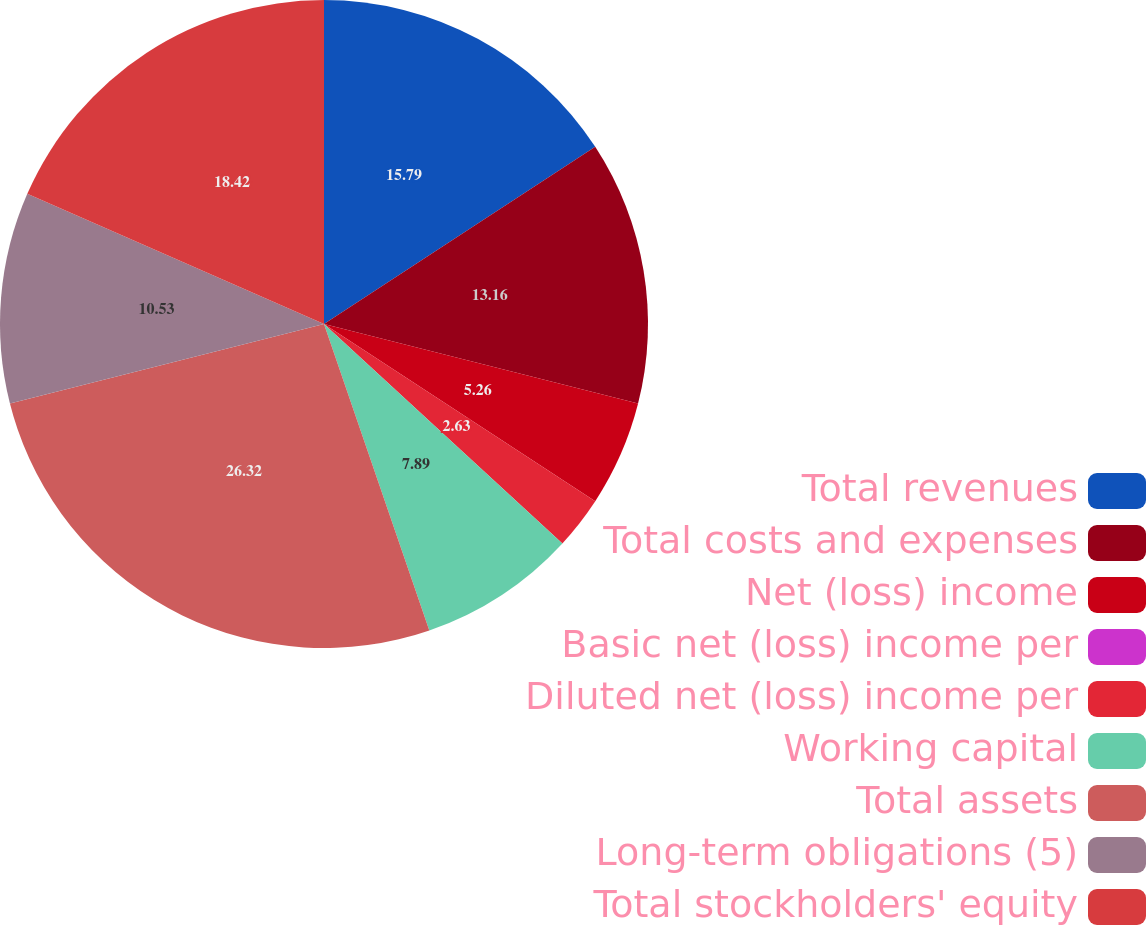Convert chart. <chart><loc_0><loc_0><loc_500><loc_500><pie_chart><fcel>Total revenues<fcel>Total costs and expenses<fcel>Net (loss) income<fcel>Basic net (loss) income per<fcel>Diluted net (loss) income per<fcel>Working capital<fcel>Total assets<fcel>Long-term obligations (5)<fcel>Total stockholders' equity<nl><fcel>15.79%<fcel>13.16%<fcel>5.26%<fcel>0.0%<fcel>2.63%<fcel>7.89%<fcel>26.32%<fcel>10.53%<fcel>18.42%<nl></chart> 